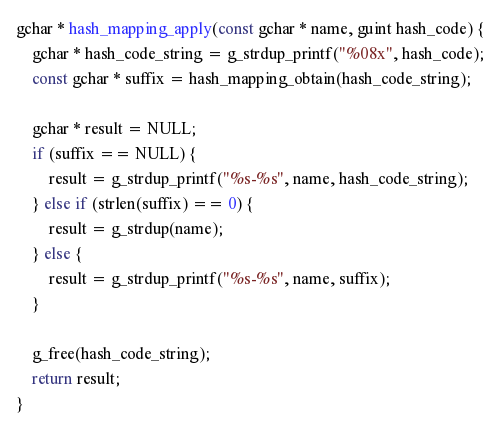Convert code to text. <code><loc_0><loc_0><loc_500><loc_500><_C_>
gchar * hash_mapping_apply(const gchar * name, guint hash_code) {
	gchar * hash_code_string = g_strdup_printf("%08x", hash_code);
	const gchar * suffix = hash_mapping_obtain(hash_code_string);

	gchar * result = NULL;
	if (suffix == NULL) {
		result = g_strdup_printf("%s-%s", name, hash_code_string);
	} else if (strlen(suffix) == 0) {
		result = g_strdup(name);
	} else {
		result = g_strdup_printf("%s-%s", name, suffix);
	}

	g_free(hash_code_string);
	return result;
}
</code> 